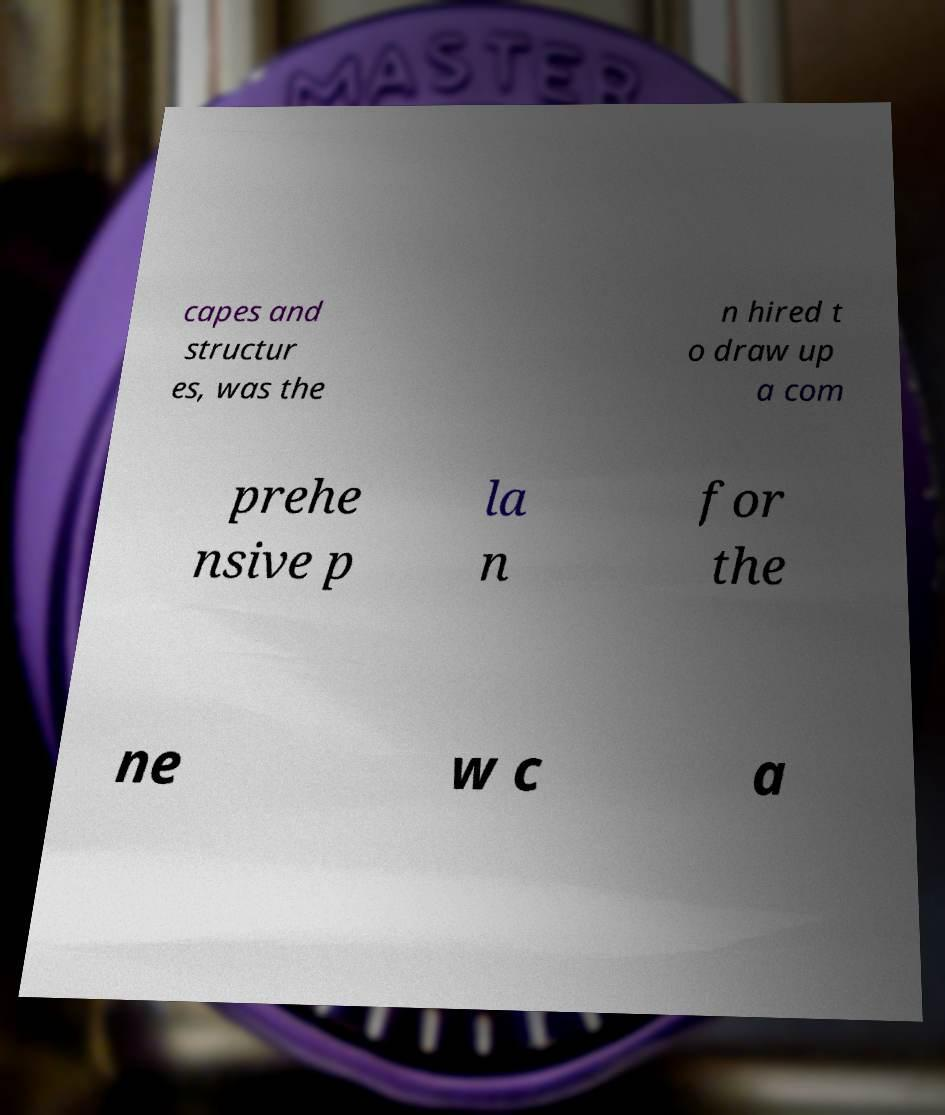Please read and relay the text visible in this image. What does it say? capes and structur es, was the n hired t o draw up a com prehe nsive p la n for the ne w c a 